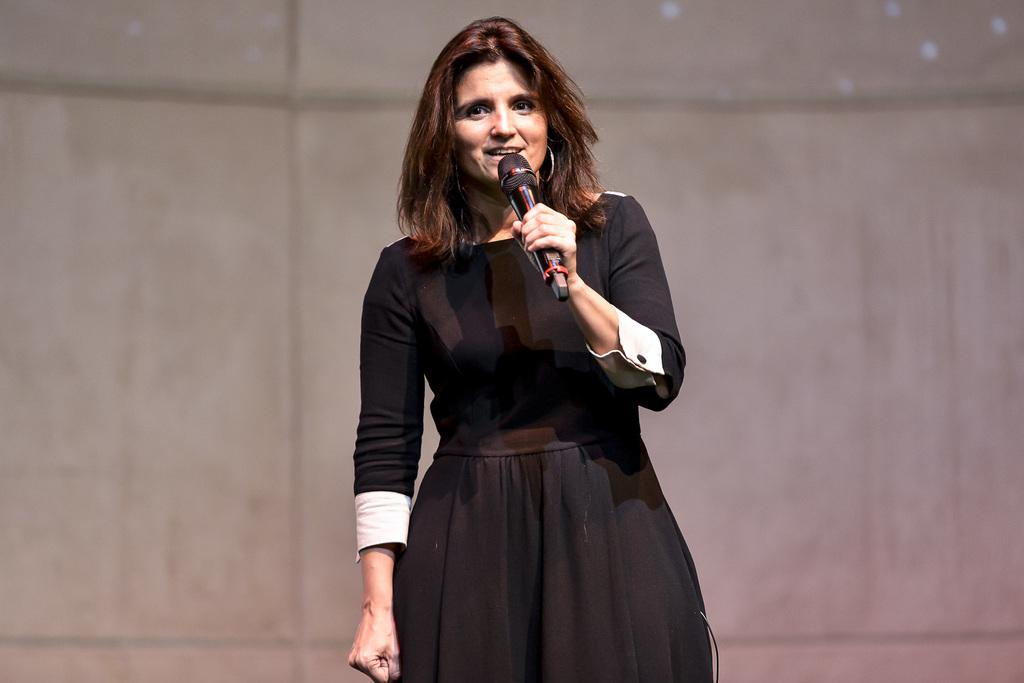What is the main subject of the image? The main subject of the image is a standing woman. What is the woman doing in the image? The woman is using a microphone in the image. What type of card is the woman holding in the image? There is no card present in the image; the woman is using a microphone. What is the woman eating for lunch in the image? There is no lunch depicted in the image; the woman is using a microphone. 